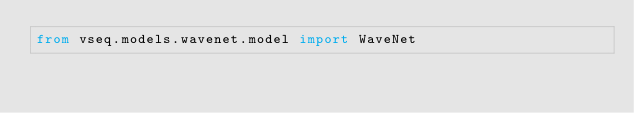Convert code to text. <code><loc_0><loc_0><loc_500><loc_500><_Python_>from vseq.models.wavenet.model import WaveNet</code> 